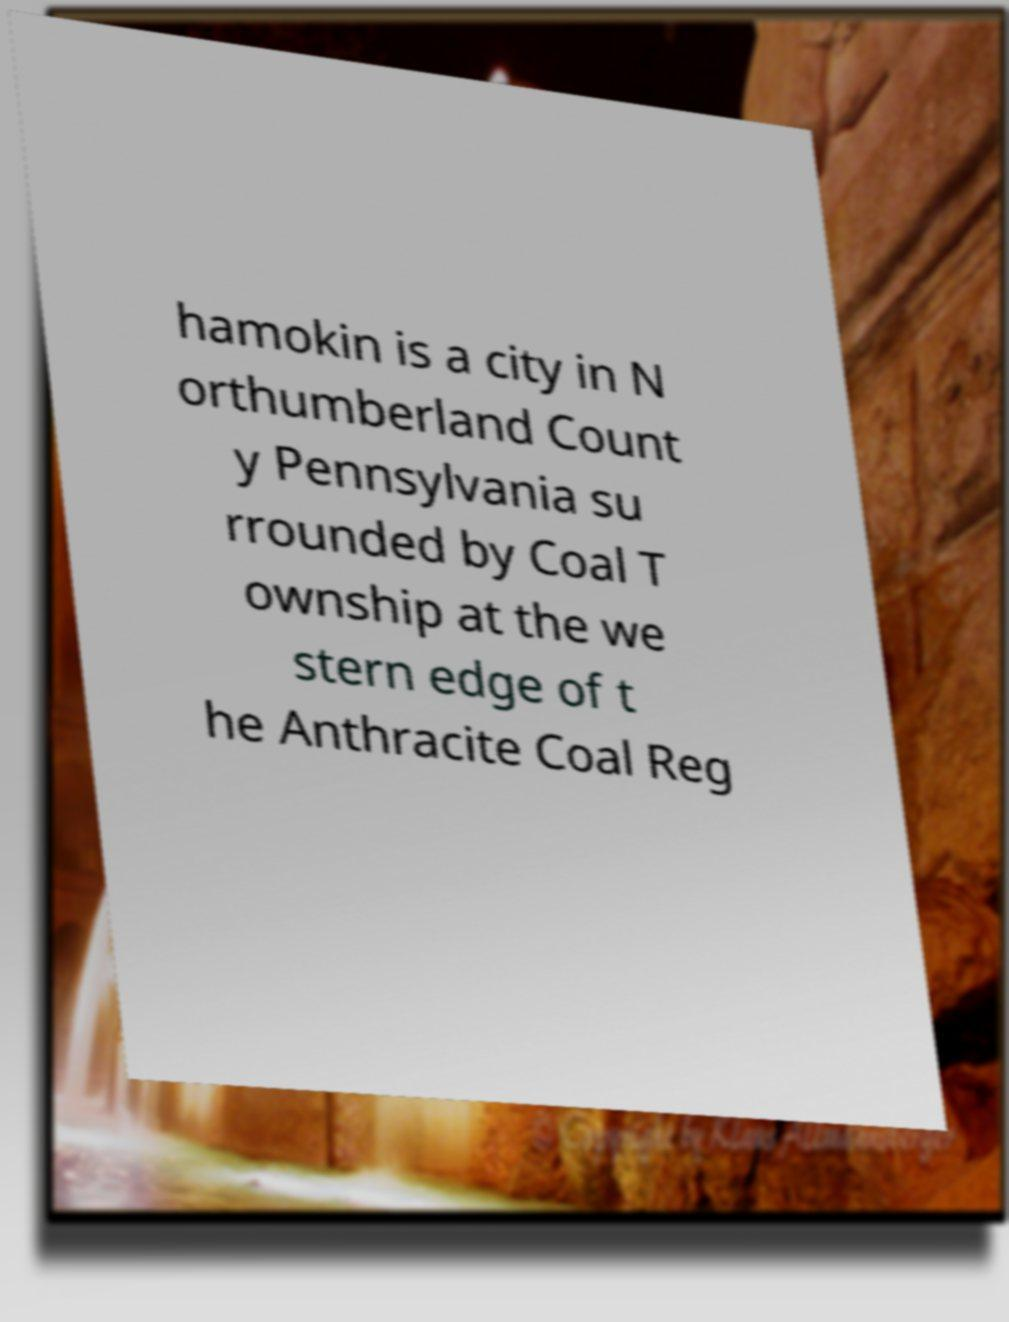I need the written content from this picture converted into text. Can you do that? hamokin is a city in N orthumberland Count y Pennsylvania su rrounded by Coal T ownship at the we stern edge of t he Anthracite Coal Reg 